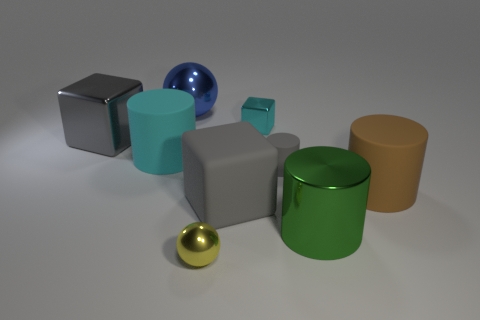Are there any large brown things to the left of the big matte object that is on the left side of the tiny yellow metal ball?
Your answer should be very brief. No. There is a big gray matte object; does it have the same shape as the thing to the right of the green metal cylinder?
Provide a short and direct response. No. What is the size of the shiny object that is both in front of the big blue metal sphere and on the left side of the small yellow metallic thing?
Your answer should be very brief. Large. Are there any green cylinders that have the same material as the small cyan cube?
Provide a succinct answer. Yes. There is a metal object that is the same color as the small matte cylinder; what size is it?
Your answer should be very brief. Large. What is the material of the block that is left of the object that is in front of the green metallic thing?
Offer a very short reply. Metal. What number of large things have the same color as the big metal cylinder?
Make the answer very short. 0. The green cylinder that is the same material as the cyan cube is what size?
Your response must be concise. Large. The large matte object that is left of the blue metal sphere has what shape?
Make the answer very short. Cylinder. There is another object that is the same shape as the blue object; what is its size?
Your response must be concise. Small. 